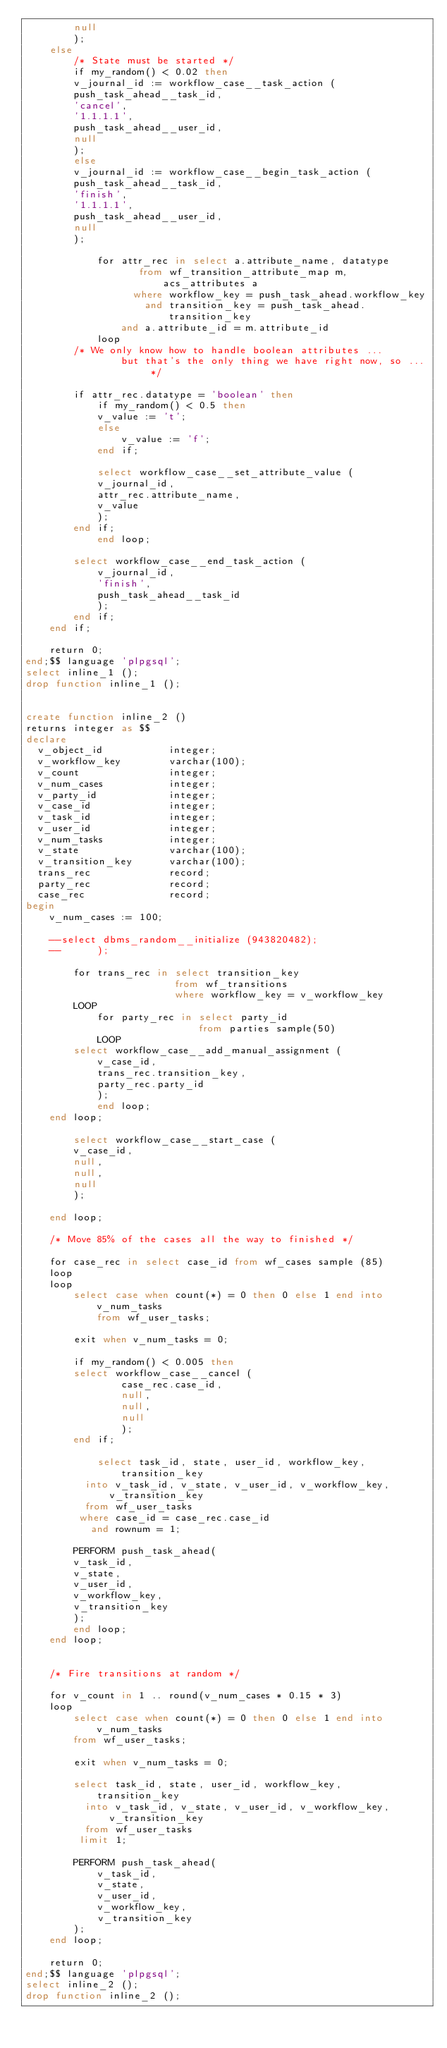<code> <loc_0><loc_0><loc_500><loc_500><_SQL_>	    null
	    );
    else
        /* State must be started */
        if my_random() < 0.02 then
	    v_journal_id := workflow_case__task_action (
		push_task_ahead__task_id,
		'cancel',
		'1.1.1.1',
		push_task_ahead__user_id,
		null
		);
        else
	    v_journal_id := workflow_case__begin_task_action (
		push_task_ahead__task_id,
		'finish',
		'1.1.1.1',
		push_task_ahead__user_id,
		null
		);

            for attr_rec in select a.attribute_name, datatype
		 	       from wf_transition_attribute_map m, acs_attributes a
			      where workflow_key = push_task_ahead.workflow_key
			        and transition_key = push_task_ahead.transition_key
				and a.attribute_id = m.attribute_id
            loop
		/* We only know how to handle boolean attributes ... 
                but that's the only thing we have right now, so ... */

	 	if attr_rec.datatype = 'boolean' then
		    if my_random() < 0.5 then
			v_value := 't';
		    else
		        v_value := 'f';
		    end if;

		    select workflow_case__set_attribute_value (
			v_journal_id,
			attr_rec.attribute_name,
			v_value
			);
 		end if;
            end loop;

	    select workflow_case__end_task_action (
	        v_journal_id,
	        'finish',
	        push_task_ahead__task_id
	        );
        end if;
    end if;

    return 0;
end;$$ language 'plpgsql';
select inline_1 ();
drop function inline_1 ();


create function inline_2 ()
returns integer as $$
declare
  v_object_id           integer;
  v_workflow_key        varchar(100);
  v_count               integer;
  v_num_cases           integer;
  v_party_id            integer;
  v_case_id             integer;
  v_task_id             integer;
  v_user_id             integer;
  v_num_tasks           integer;
  v_state               varchar(100);
  v_transition_key      varchar(100);
  trans_rec             record;
  party_rec             record;
  case_rec              record;
begin
    v_num_cases := 100;

    --select dbms_random__initialize (943820482);
    --	    );

        for trans_rec in select transition_key 
                         from wf_transitions 
                         where workflow_key = v_workflow_key
        LOOP
            for party_rec in select party_id 
                             from parties sample(50) 
            LOOP
		select workflow_case__add_manual_assignment (
		    v_case_id,
		    trans_rec.transition_key,
		    party_rec.party_id
		    );
     	    end loop;
	end loop;

        select workflow_case__start_case (
	    v_case_id,
	    null,
	    null,
	    null
	    );

    end loop;

    /* Move 85% of the cases all the way to finished */

    for case_rec in select case_id from wf_cases sample (85)
    loop
	loop
	    select case when count(*) = 0 then 0 else 1 end into v_num_tasks 
            from wf_user_tasks;

	    exit when v_num_tasks = 0;

	    if my_random() < 0.005 then
		select workflow_case__cancel (
	            case_rec.case_id,
	            null,
	            null,
	            null
	            );
	    end if;

            select task_id, state, user_id, workflow_key, transition_key
	      into v_task_id, v_state, v_user_id, v_workflow_key, v_transition_key
	      from wf_user_tasks
	     where case_id = case_rec.case_id
	       and rownum = 1;

	    PERFORM push_task_ahead(
		v_task_id,
		v_state,
		v_user_id,
		v_workflow_key,
		v_transition_key
	    );	    
        end loop;
    end loop;


    /* Fire transitions at random */

    for v_count in 1 .. round(v_num_cases * 0.15 * 3)
    loop
        select case when count(*) = 0 then 0 else 1 end into v_num_tasks 
        from wf_user_tasks;

        exit when v_num_tasks = 0;

        select task_id, state, user_id, workflow_key, transition_key
          into v_task_id, v_state, v_user_id, v_workflow_key, v_transition_key
          from wf_user_tasks
         limit 1;

        PERFORM push_task_ahead(
            v_task_id,
            v_state,
            v_user_id,
            v_workflow_key,
            v_transition_key
        );	    
    end loop;

    return 0;
end;$$ language 'plpgsql';
select inline_2 ();
drop function inline_2 ();


</code> 